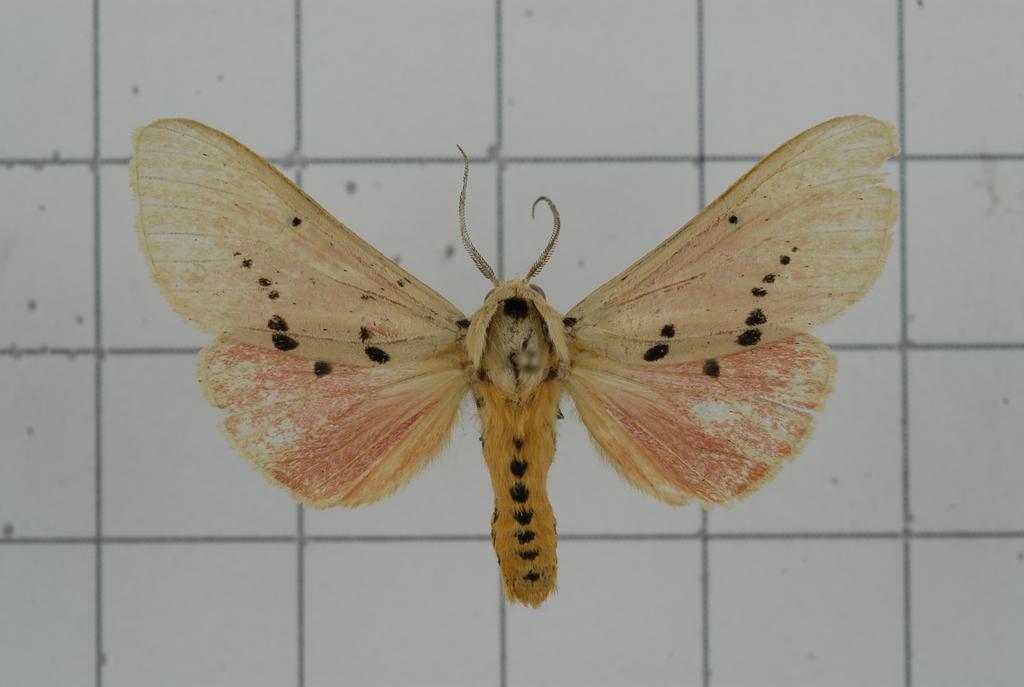Please provide a concise description of this image. In this picture, there is a butterfly which is in brown and cream in color. In the background, there is a wall with lines. 